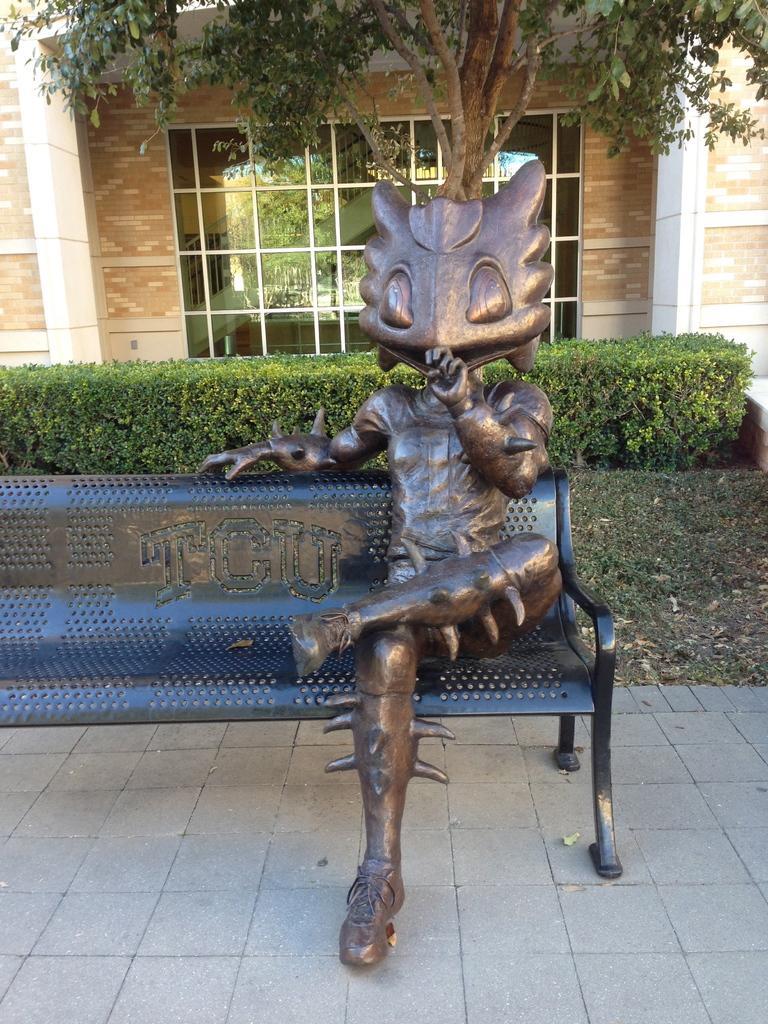Can you describe this image briefly? In this picture we can see a statue on the bench and behind the bench there are plants, tree and a wall with a glass window. Behind the window we can see the staircase. 